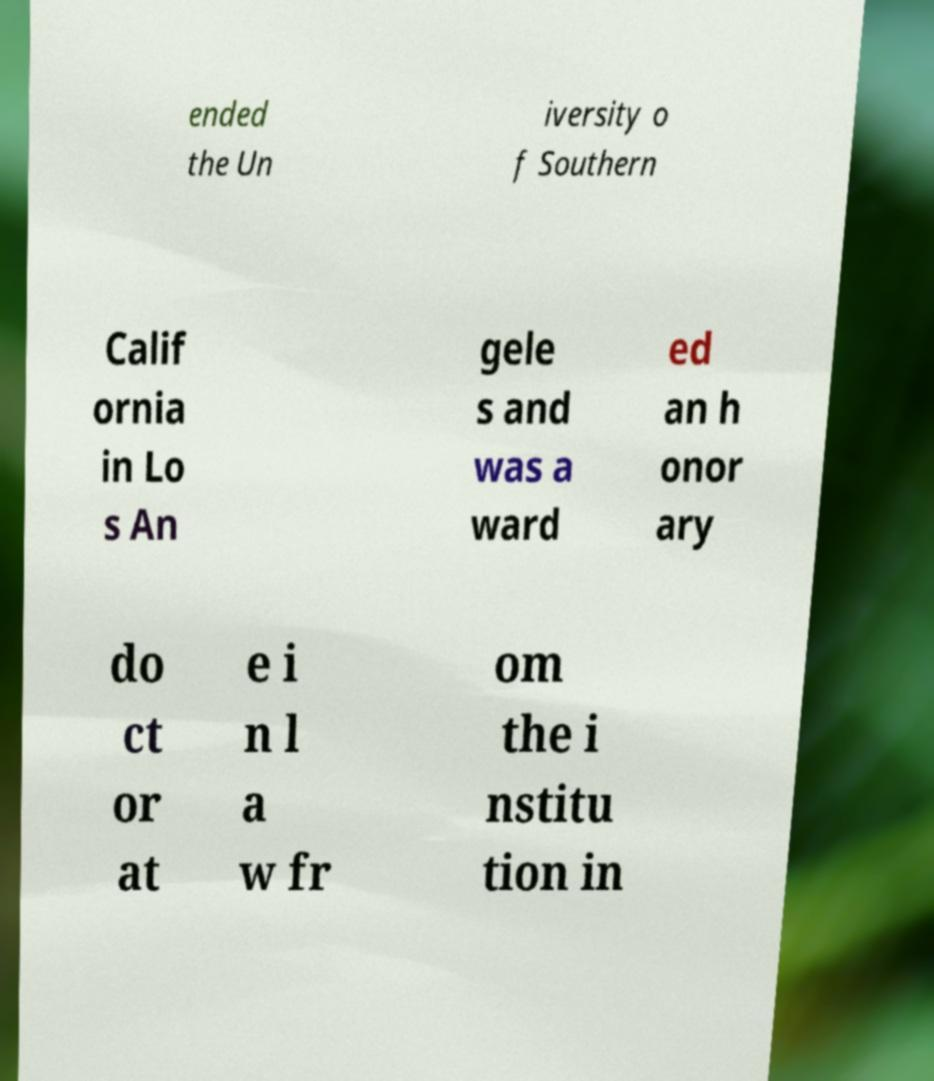Could you assist in decoding the text presented in this image and type it out clearly? ended the Un iversity o f Southern Calif ornia in Lo s An gele s and was a ward ed an h onor ary do ct or at e i n l a w fr om the i nstitu tion in 